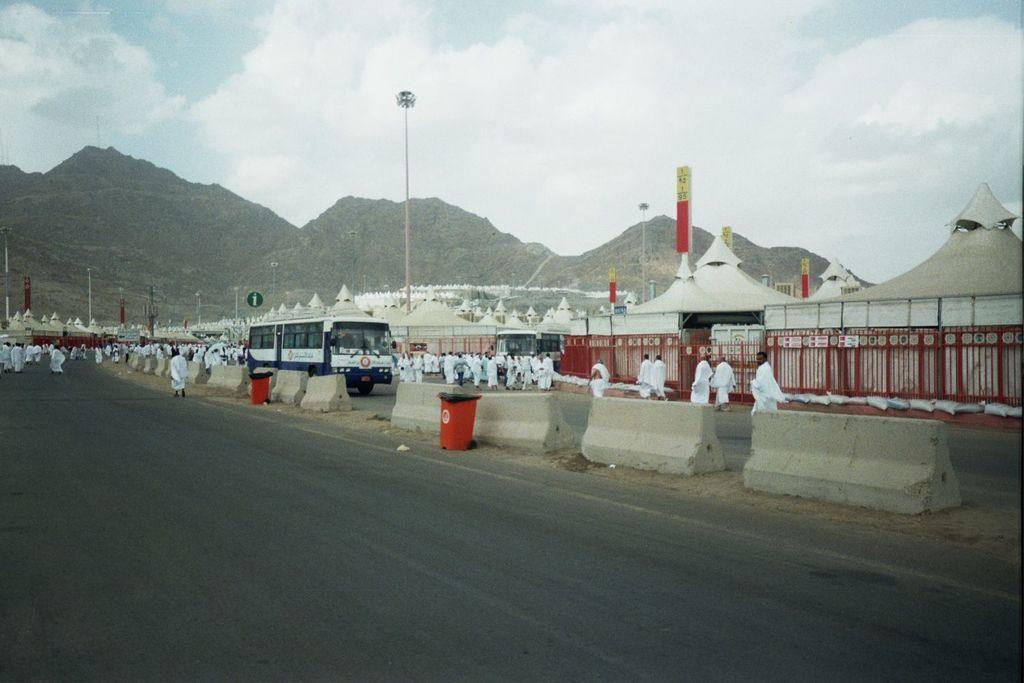Can you describe this image briefly? It looks like some pilgrimage,lot of people are walking on a path by wearing white costumes,there are plenty of tents around the people and beside the road there is a bus. In the background there are few mountains. 